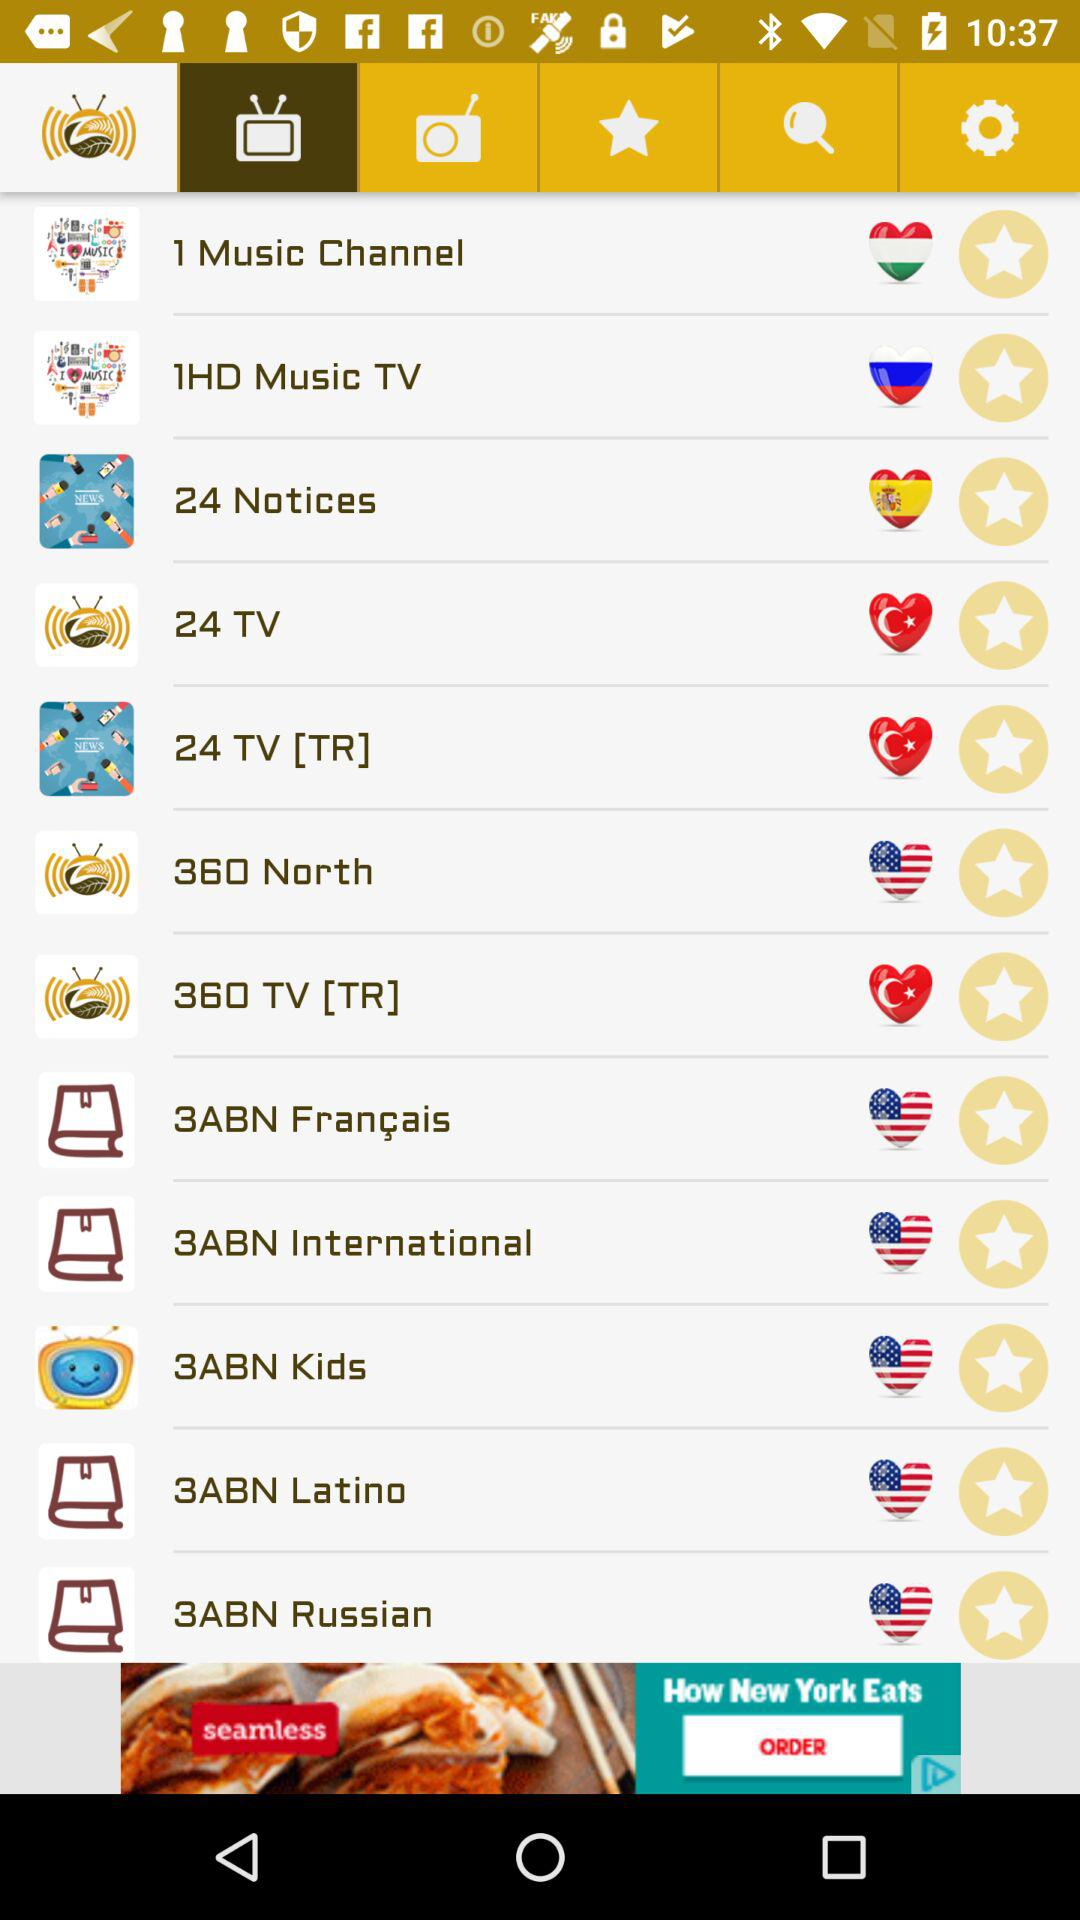What is the television channel name for kids? The television channel name is "3ABN Kids". 